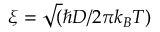Convert formula to latex. <formula><loc_0><loc_0><loc_500><loc_500>\xi = \sqrt { ( } \hbar { D } / 2 \pi k _ { B } T )</formula> 